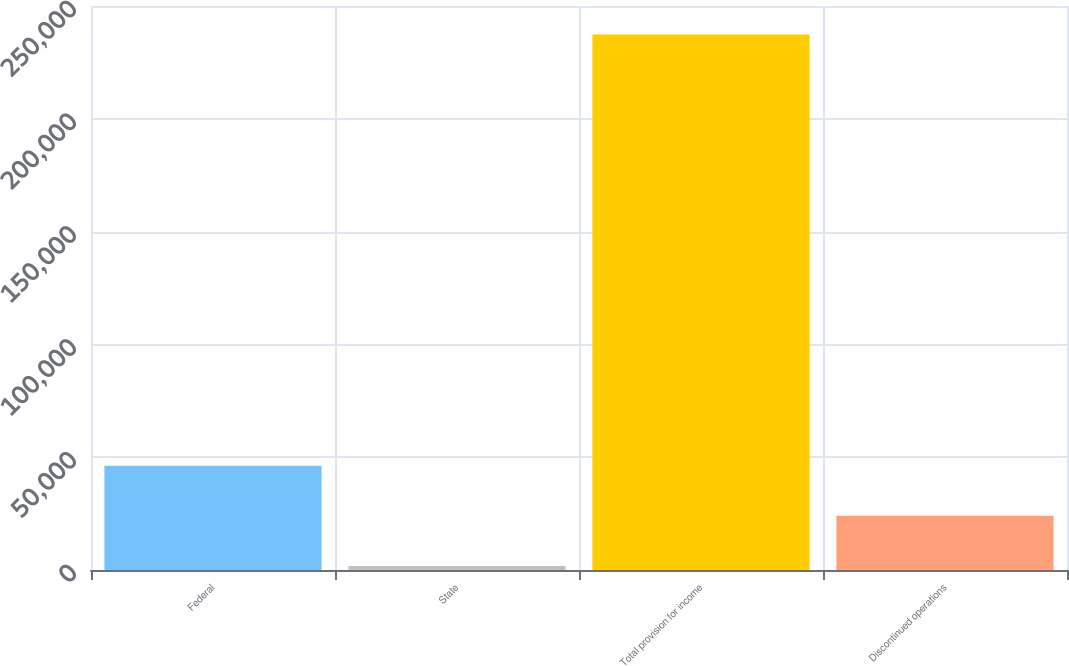Convert chart to OTSL. <chart><loc_0><loc_0><loc_500><loc_500><bar_chart><fcel>Federal<fcel>State<fcel>Total provision for income<fcel>Discontinued operations<nl><fcel>46227.2<fcel>1798<fcel>237410<fcel>24012.6<nl></chart> 